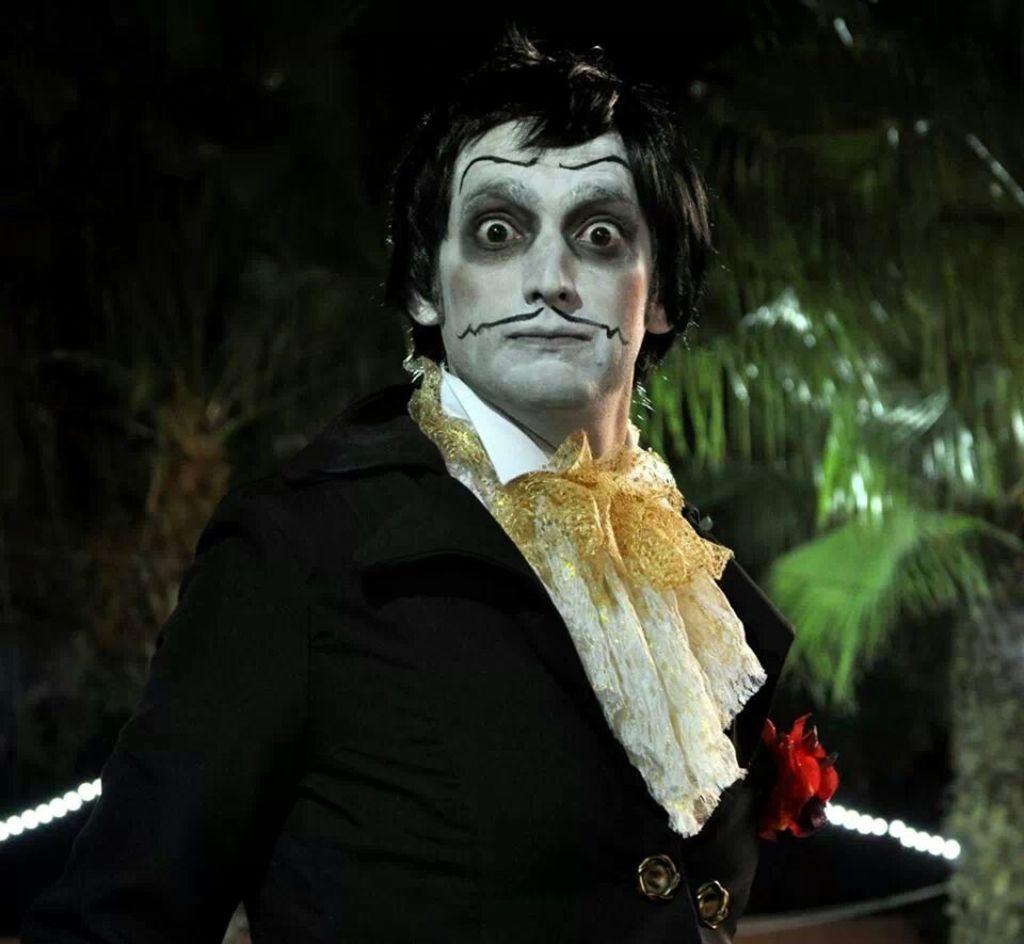Can you describe this image briefly? In this picture there is a person with makeup on his face. In the background there are trees and lights. 